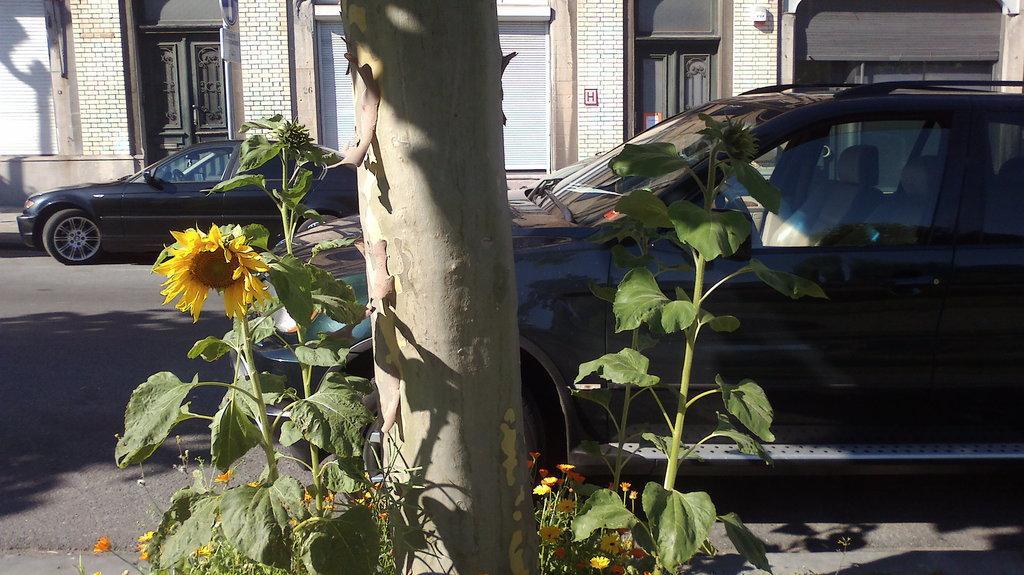Can you describe this image briefly? In this picture we can see two cars here, there is a tree here, we can see a flower here, in the background there is a building, we can see a door here, on the left side there is a shutter. 